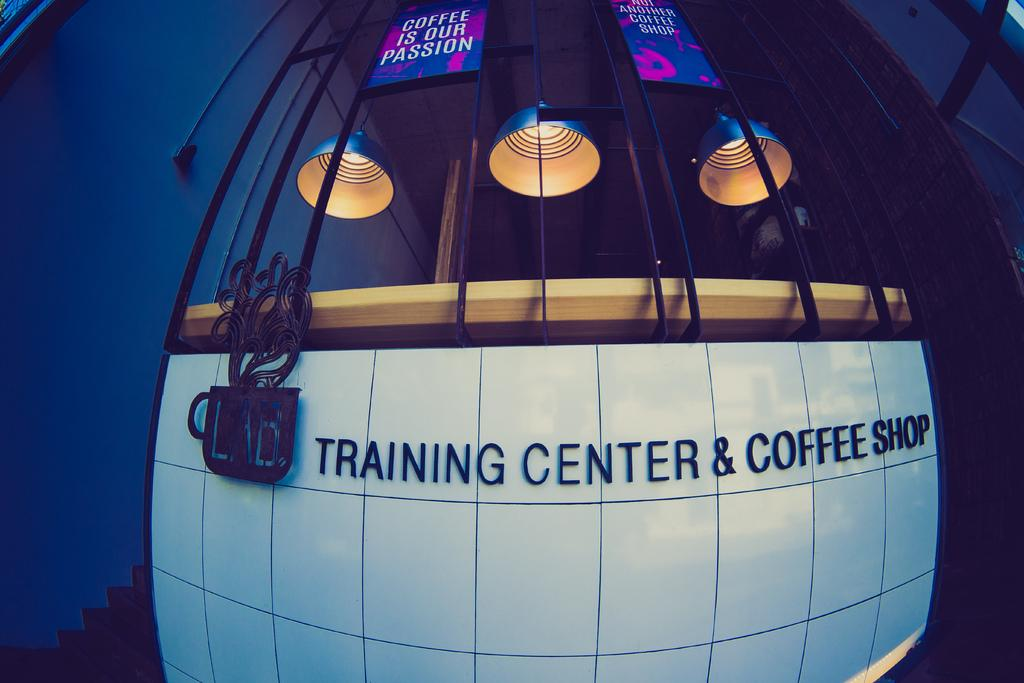Provide a one-sentence caption for the provided image. a building called trining center and coffee shop. 